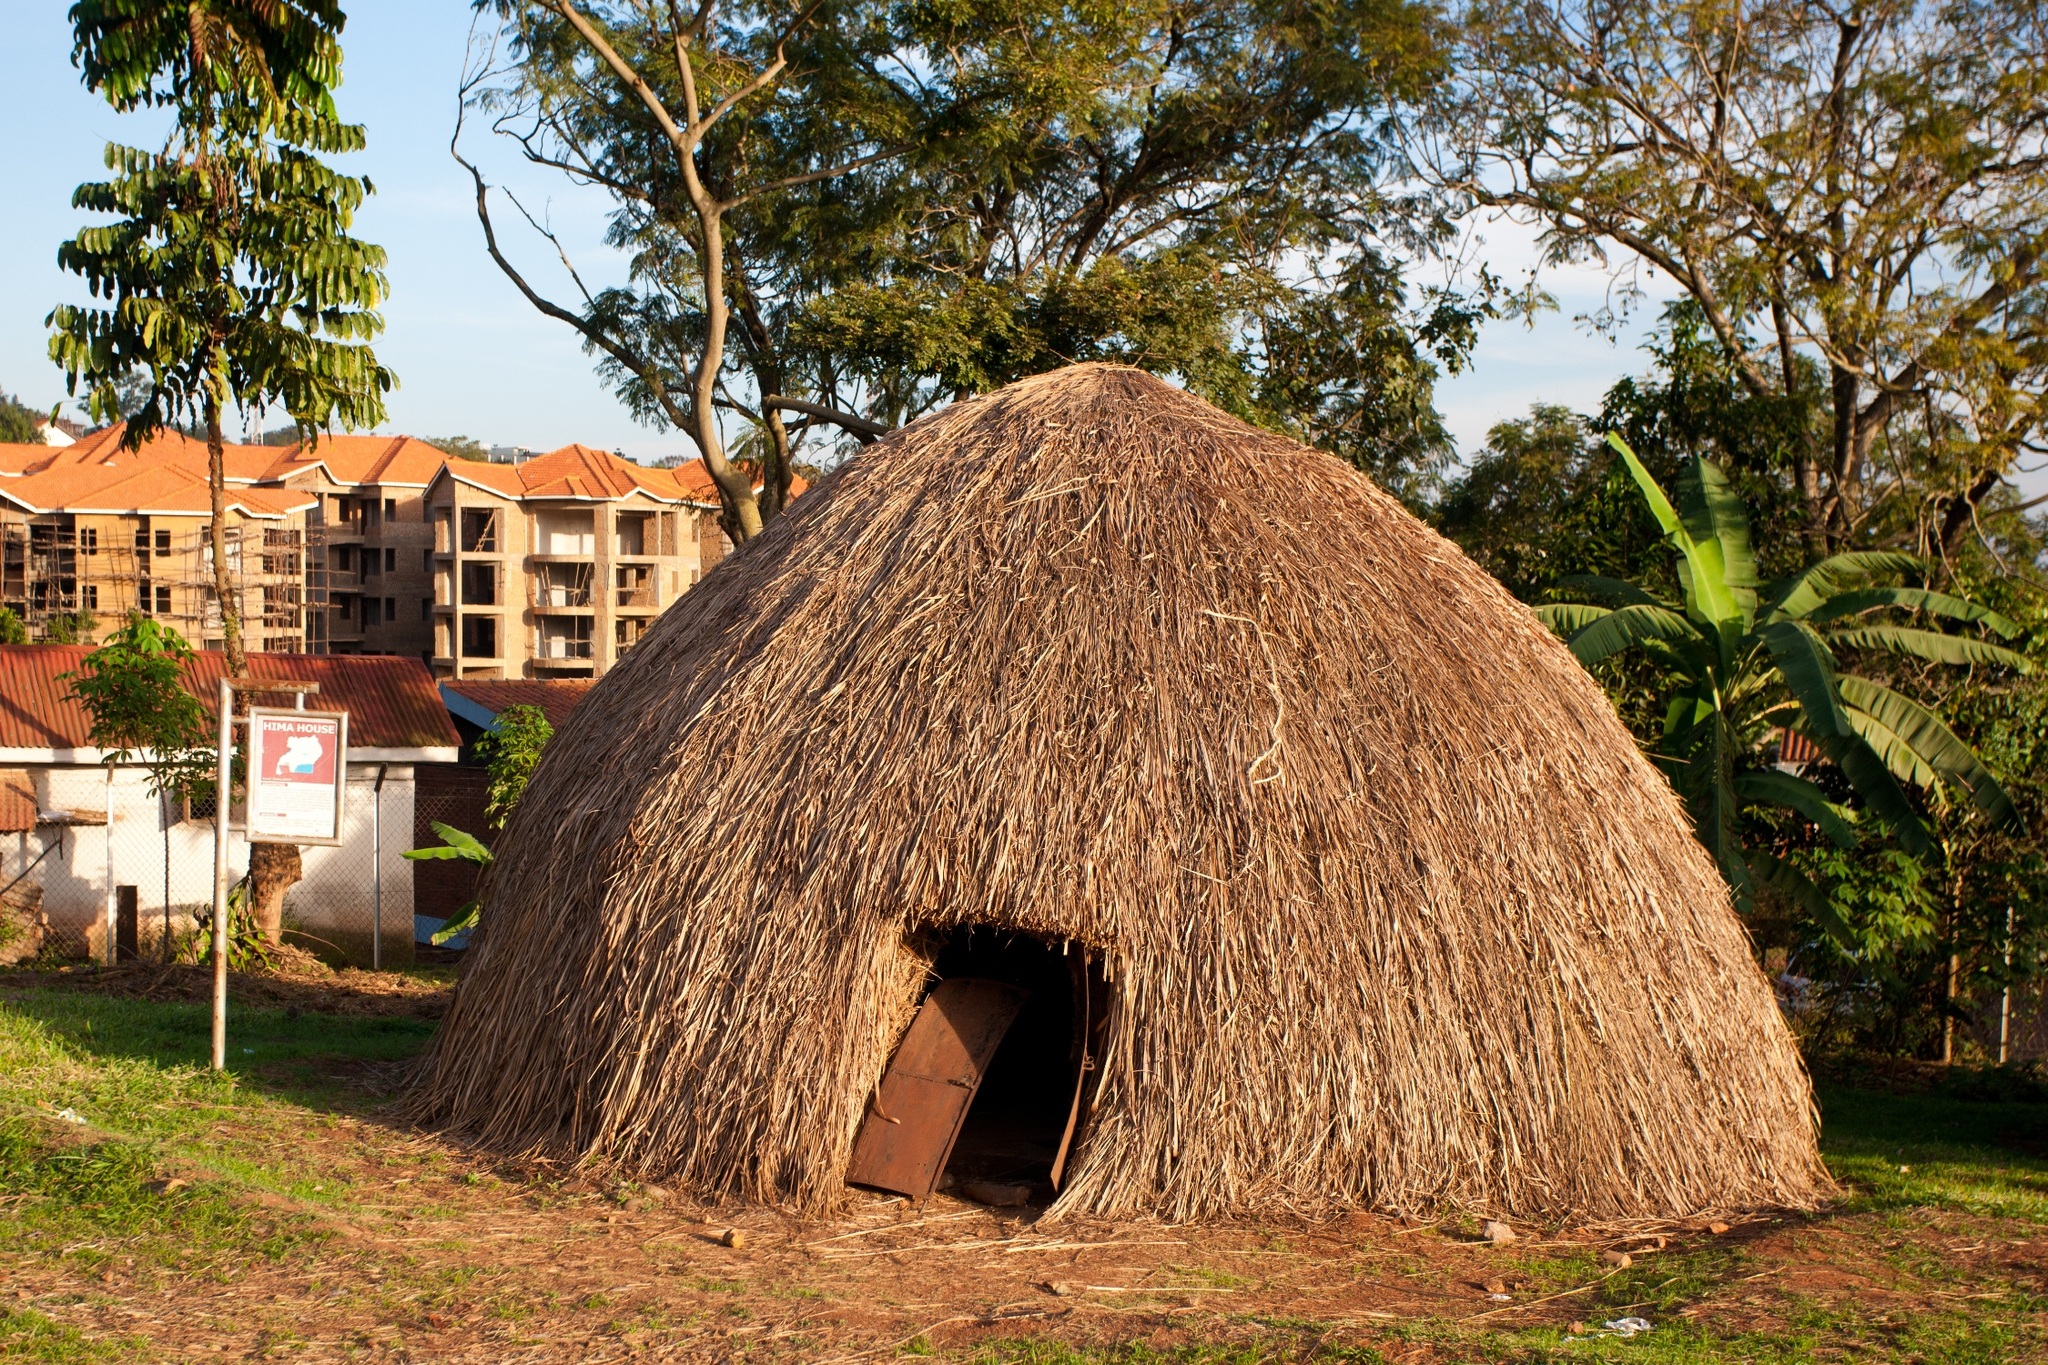Can you elaborate on the elements of the picture provided? The image captures a scene of tranquility and simplicity. At the heart of the image is a traditional African hut, its structure crafted from thatched grass, radiating a warm brown hue. The hut's wooden door, a darker shade of brown, stands in the center, serving as a welcoming entrance.

The hut is situated on a patch of dirt, surrounded by a lush, grassy area. The verdant green of the grass contrasts beautifully with the brown of the hut, creating a harmonious blend of natural colors.

In the background, a few trees stand tall, their green leaves adding to the overall serenity of the scene. Further back, beige buildings can be seen, their presence subtly reminding us of the proximity of modern civilization.

Above it all, the sky stretches out in a vast expanse of blue, dotted here and there with a few white clouds. The blue of the sky provides a calming backdrop to the scene, completing the picture of a peaceful, rural setting. 

Despite the simplicity of the scene, there's a sense of harmony and balance in the image, with each element - the hut, the grass, the trees, the buildings, and the sky - contributing to a beautifully composed snapshot of rural life. 